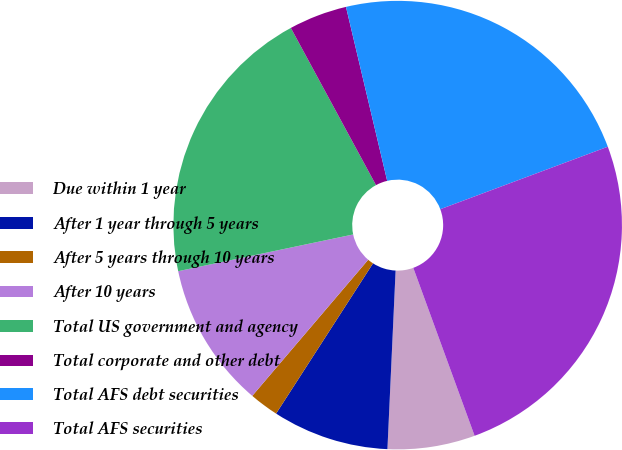<chart> <loc_0><loc_0><loc_500><loc_500><pie_chart><fcel>Due within 1 year<fcel>After 1 year through 5 years<fcel>After 5 years through 10 years<fcel>After 10 years<fcel>Total US government and agency<fcel>Total corporate and other debt<fcel>Total AFS debt securities<fcel>Total AFS securities<nl><fcel>6.3%<fcel>8.39%<fcel>2.11%<fcel>10.48%<fcel>20.39%<fcel>4.2%<fcel>23.02%<fcel>25.11%<nl></chart> 